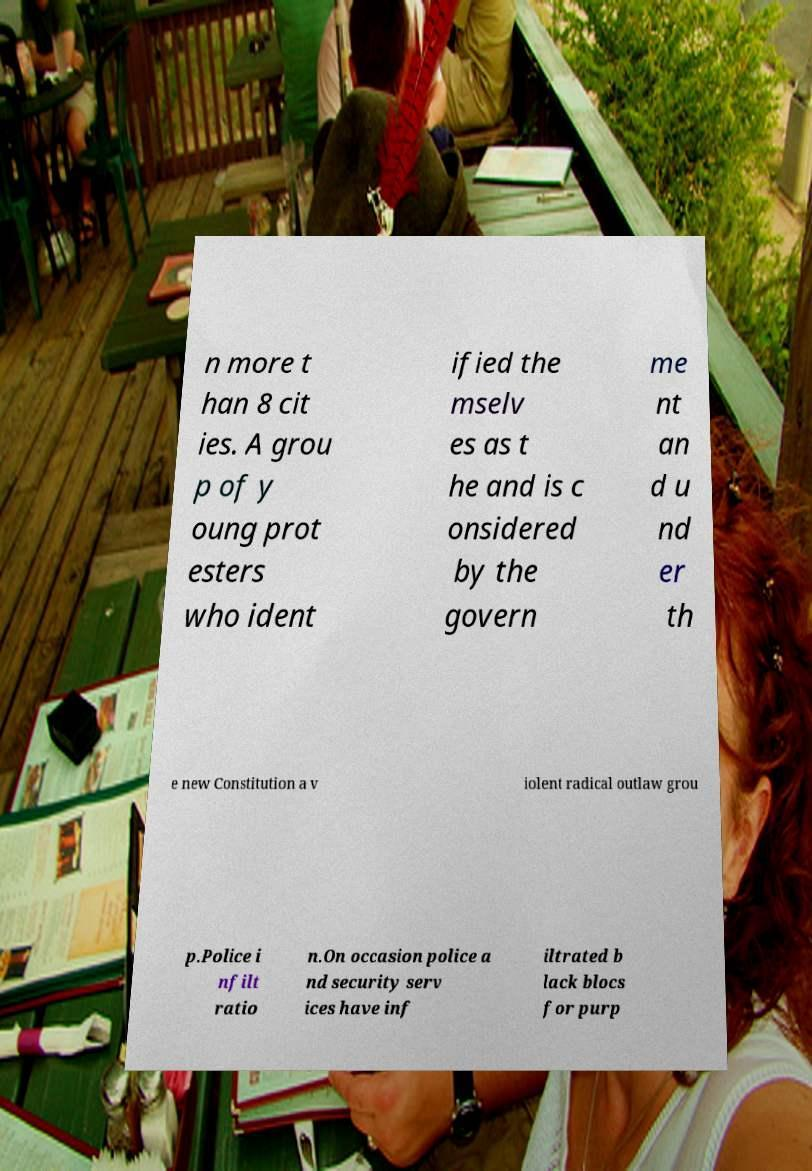Please read and relay the text visible in this image. What does it say? n more t han 8 cit ies. A grou p of y oung prot esters who ident ified the mselv es as t he and is c onsidered by the govern me nt an d u nd er th e new Constitution a v iolent radical outlaw grou p.Police i nfilt ratio n.On occasion police a nd security serv ices have inf iltrated b lack blocs for purp 